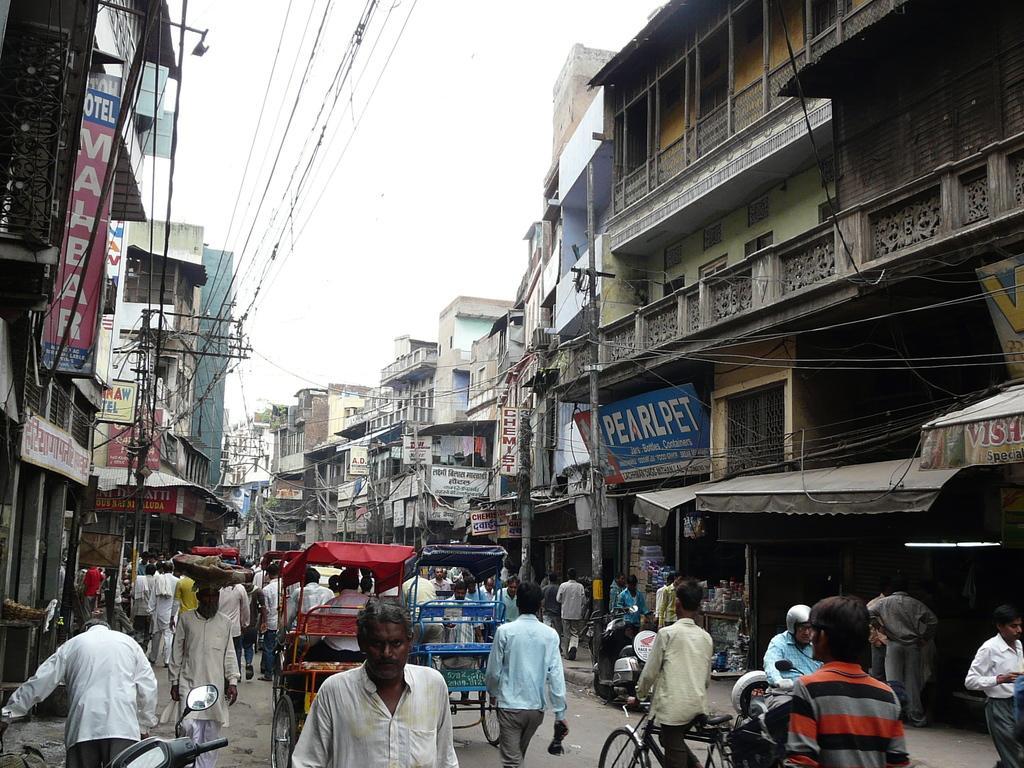In one or two sentences, can you explain what this image depicts? In the picture we can see a street with a road on it, we can see some people are walking and some people are riding rickshaws and some are riding motorcycles and beside to them, we can see, full of buildings with shops to it and near to it we can see some poles with electric wires and in the background we can see a sky. 